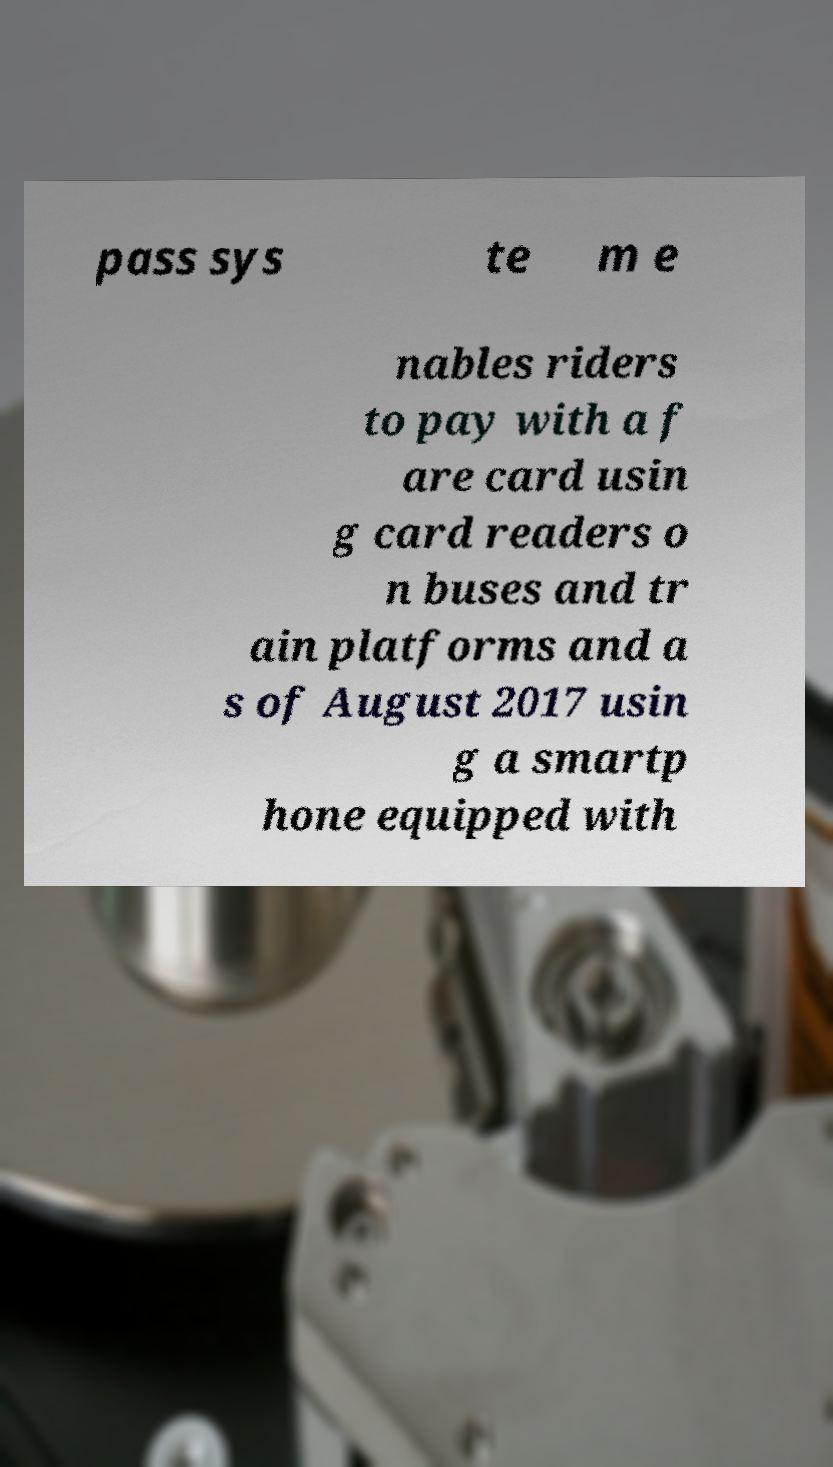Could you assist in decoding the text presented in this image and type it out clearly? pass sys te m e nables riders to pay with a f are card usin g card readers o n buses and tr ain platforms and a s of August 2017 usin g a smartp hone equipped with 